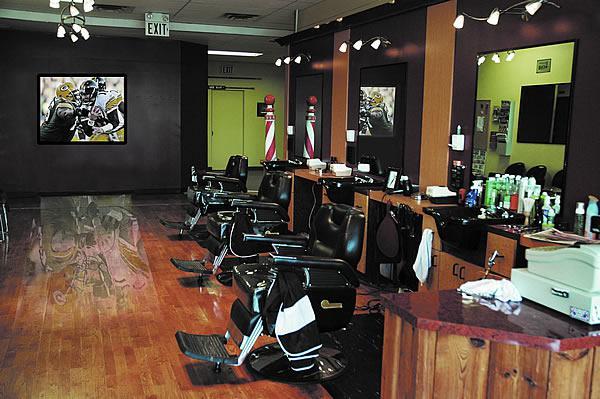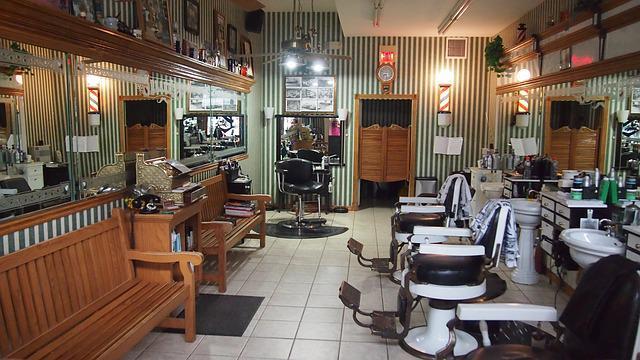The first image is the image on the left, the second image is the image on the right. Evaluate the accuracy of this statement regarding the images: "The decor in one image features black surfaces predominantly.". Is it true? Answer yes or no. Yes. 